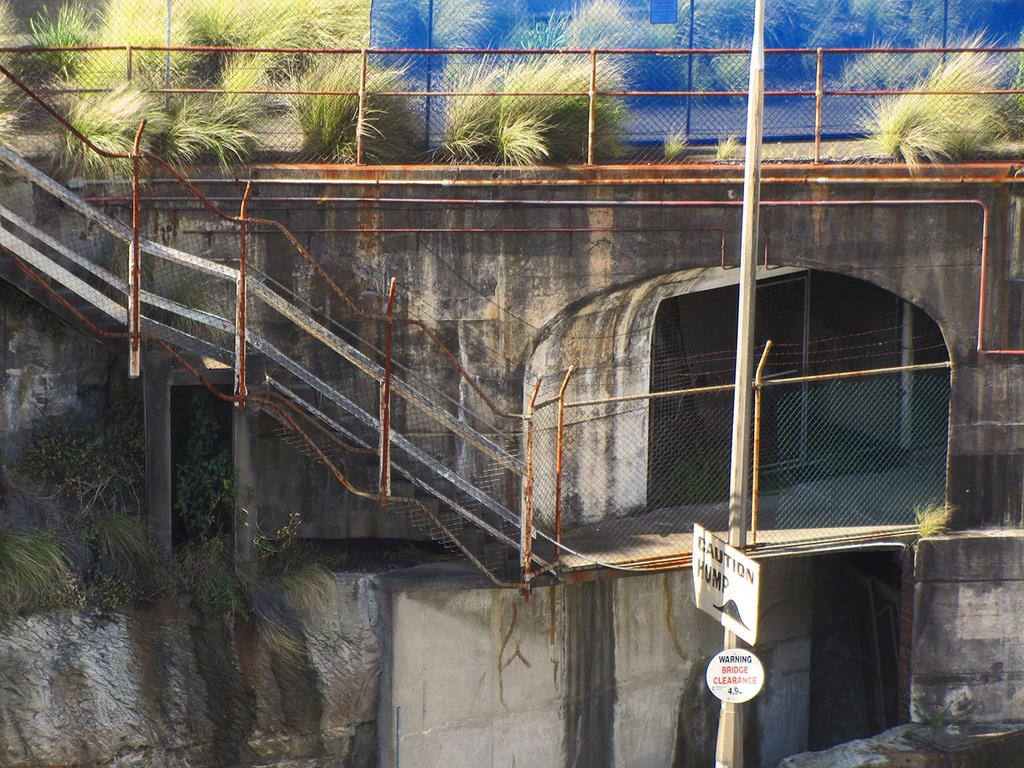What is the main structure in the image? There is a pole in the image. What other objects can be seen around the pole? There are boards, fencing, railings, and bushes in the image. Is there any text or writing present in the image? Yes, there is writing on the boards or other surfaces in the image. How many cakes are being served in the image? There are no cakes present in the image. Can you see a toad sitting on the pole in the image? There is no toad present in the image. 